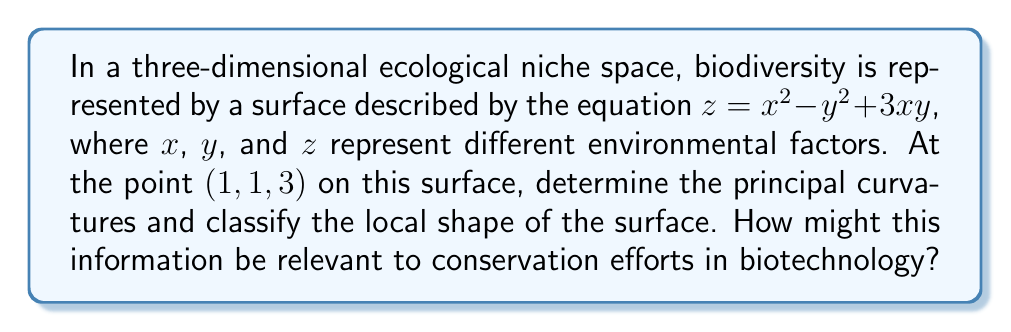Could you help me with this problem? To analyze the geometric properties of the surface at the given point, we'll follow these steps:

1) First, we need to calculate the first and second partial derivatives:
   $f_x = 2x + 3y$
   $f_y = -2y + 3x$
   $f_{xx} = 2$
   $f_{yy} = -2$
   $f_{xy} = f_{yx} = 3$

2) At the point (1, 1, 3), we evaluate:
   $f_x(1,1) = 5$
   $f_y(1,1) = 1$

3) Now we can form the first and second fundamental forms:
   First fundamental form:
   $$E = 1 + f_x^2 = 1 + 25 = 26$$
   $$F = f_x f_y = 5 \cdot 1 = 5$$
   $$G = 1 + f_y^2 = 1 + 1 = 2$$

   Second fundamental form:
   $$L = \frac{f_{xx}}{\sqrt{1+f_x^2+f_y^2}} = \frac{2}{\sqrt{1+25+1}} = \frac{2}{\sqrt{27}}$$
   $$M = \frac{f_{xy}}{\sqrt{1+f_x^2+f_y^2}} = \frac{3}{\sqrt{27}}$$
   $$N = \frac{f_{yy}}{\sqrt{1+f_x^2+f_y^2}} = \frac{-2}{\sqrt{27}}$$

4) The principal curvatures are the eigenvalues of the shape operator, which can be found by solving:
   $$\det\begin{pmatrix}
   L-kE & M-kF \\
   M-kF & N-kG
   \end{pmatrix} = 0$$

   This leads to the quadratic equation:
   $$(L-kE)(N-kG) - (M-kF)^2 = 0$$

5) Substituting the values and simplifying:
   $$(\frac{2}{\sqrt{27}}-26k)(\frac{-2}{\sqrt{27}}-2k) - (\frac{3}{\sqrt{27}}-5k)^2 = 0$$

6) Solving this quadratic equation gives us the principal curvatures:
   $k_1 \approx 0.1925$ and $k_2 \approx -0.1925$

7) Since the principal curvatures have opposite signs, the surface at this point is a saddle point.

This information is relevant to conservation efforts in biotechnology because:
- The saddle shape indicates a complex interplay between environmental factors.
- Areas of high curvature may represent sensitive regions in the ecological niche space where small changes in environmental factors could lead to significant changes in biodiversity.
- Understanding these geometric properties can help in designing targeted biotechnological interventions to maintain or enhance biodiversity in specific ecological niches.
Answer: Principal curvatures: $k_1 \approx 0.1925$, $k_2 \approx -0.1925$. Surface shape: Saddle point. 